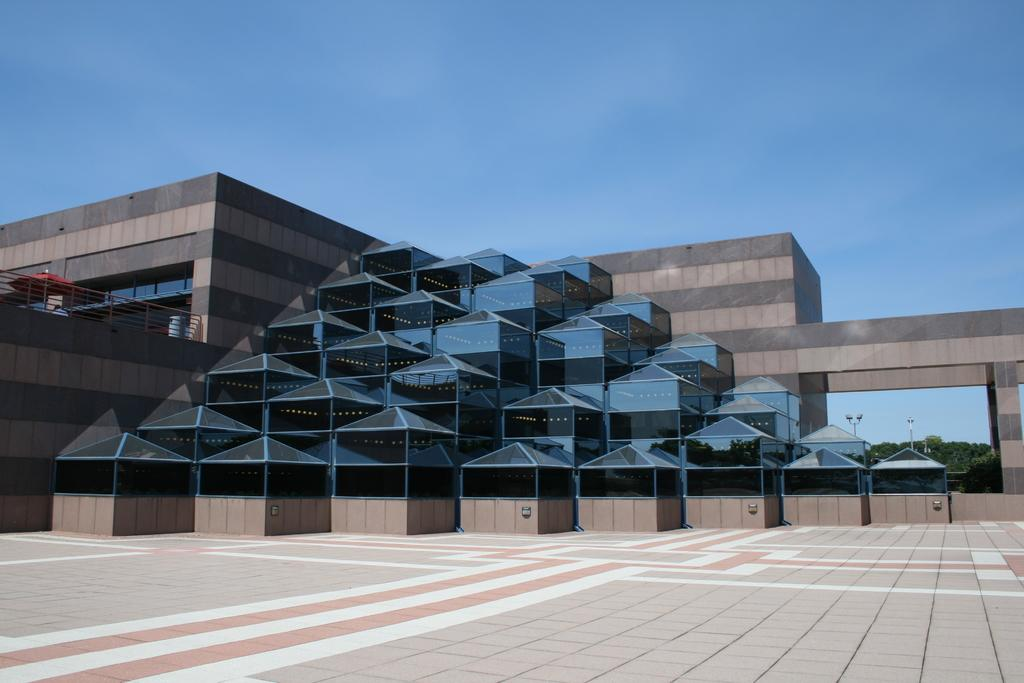What can be seen on the ground in the image? The floor is visible in the image. What type of structure is present in the image? There is a building in the image. What object is used for protection from rain in the image? An umbrella is present in the image. What type of barrier is present in the image? There is a fence in the image. What type of vegetation is visible in the image? Trees are visible in the image. What type of vertical structures are present in the image? Poles are present in the image. What other objects can be seen in the image besides those mentioned? There are other objects in the image. What is visible in the background of the image? The sky is visible in the background of the image. What type of net is used to catch the falling objects in the image? There is no net present in the image, and no objects are falling. 